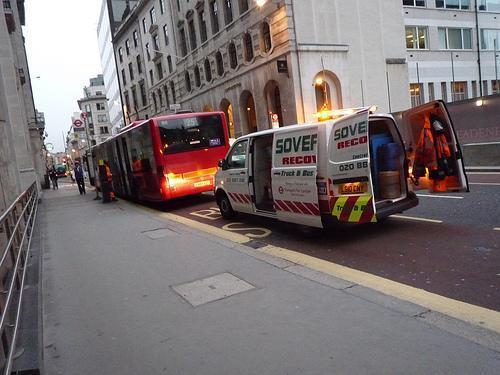How many buses are there?
Give a very brief answer. 1. 